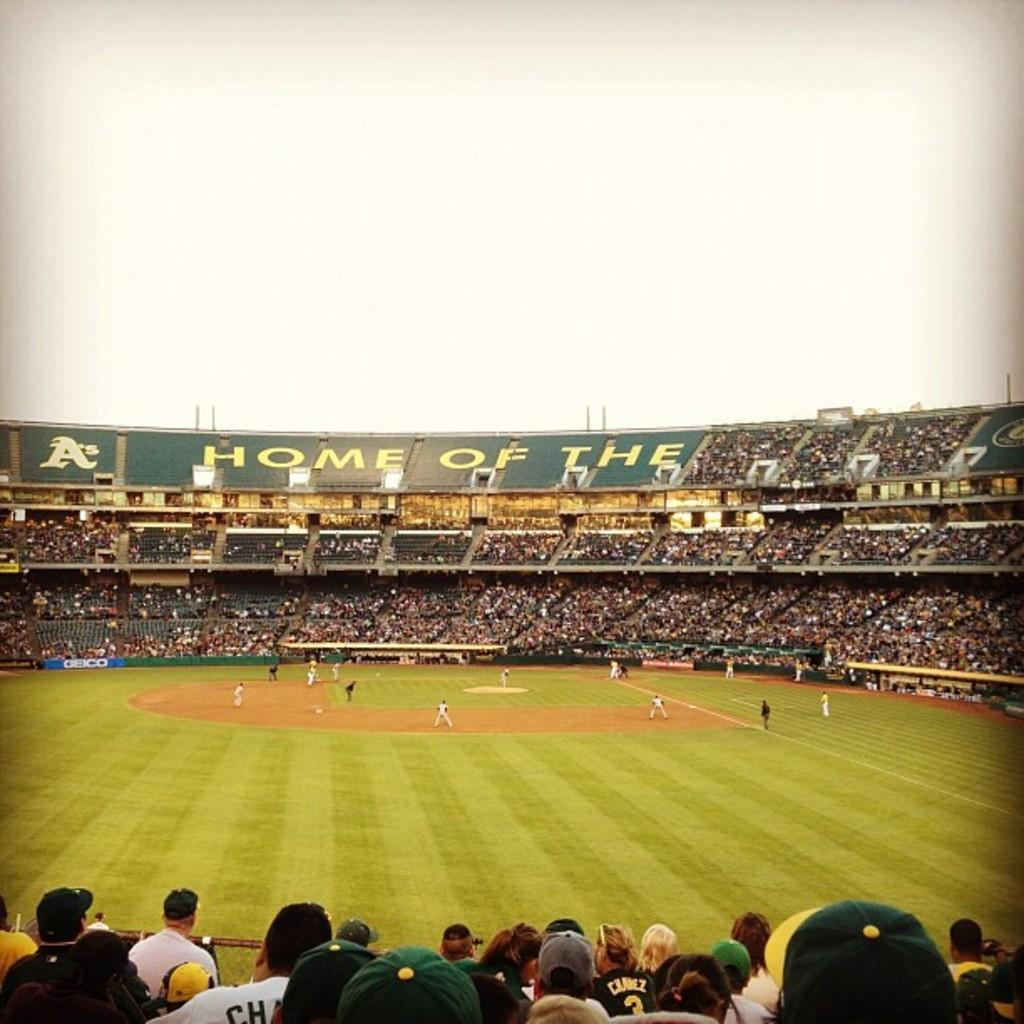<image>
Write a terse but informative summary of the picture. A stadium has a large banner that says "Home of the" 